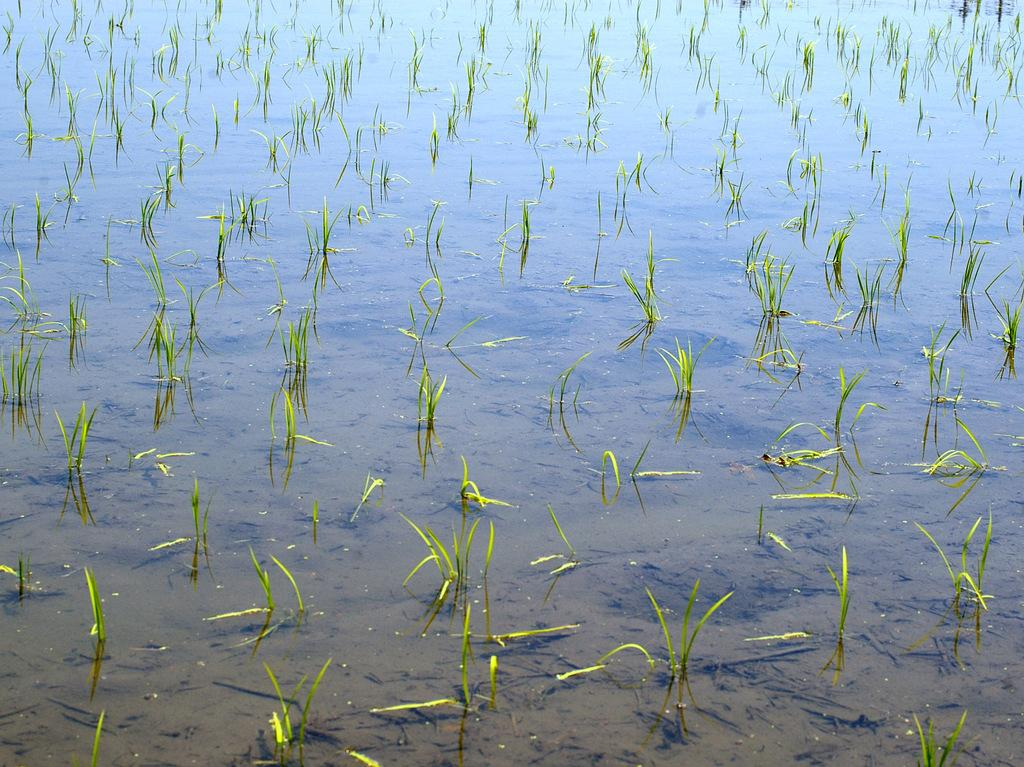What can be seen in the image that is not solid? There is water visible in the image. What type of ground is present in the image? There is brown-colored soil in the image. What type of vegetation is present in the image? There is green grass in the image. What type of hen can be seen participating in the discussion in the image? There is no hen or discussion present in the image. What type of learning material can be seen in the image? There is no learning material present in the image. 